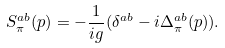<formula> <loc_0><loc_0><loc_500><loc_500>S _ { \pi } ^ { a b } ( p ) = - \frac { 1 } { i g } ( \delta ^ { a b } - i \Delta _ { \pi } ^ { a b } ( p ) ) .</formula> 